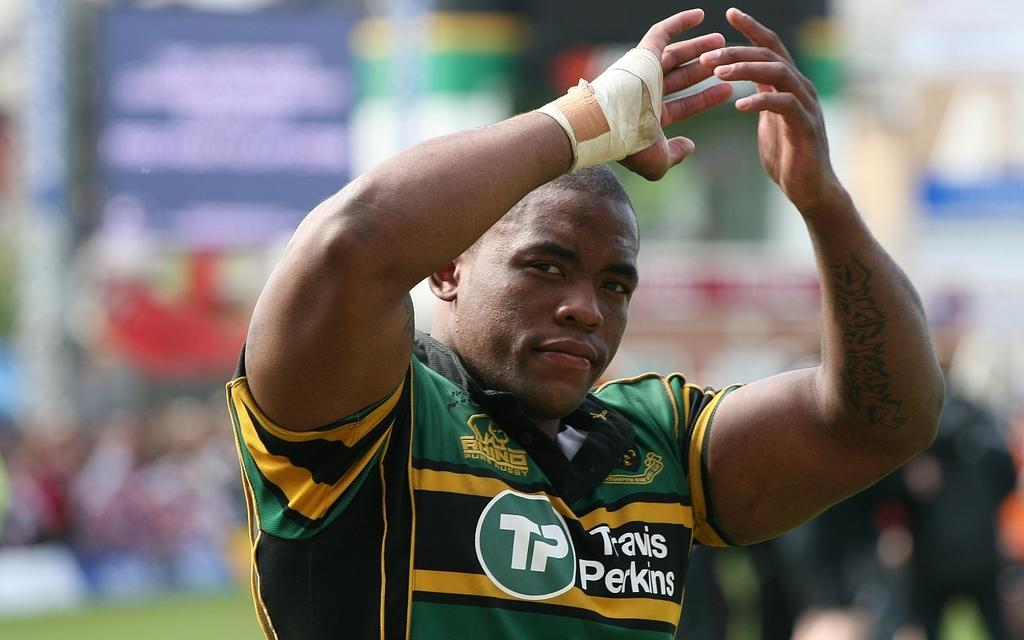<image>
Present a compact description of the photo's key features. A black male athlete wearing the team name Travis Perkins  holding his arms up in the air. 